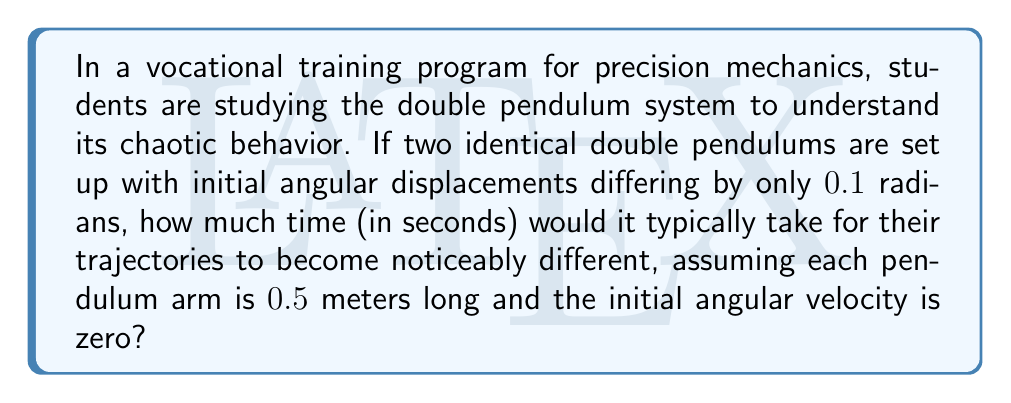Solve this math problem. To solve this problem, we need to consider the Lyapunov exponent of a double pendulum system. The Lyapunov exponent measures the rate at which nearby trajectories separate.

Step 1: The Lyapunov exponent for a double pendulum is approximately:
$$\lambda \approx \sqrt{\frac{g}{l}}$$
where $g$ is the acceleration due to gravity (9.8 m/s^2) and $l$ is the length of each pendulum arm.

Step 2: Calculate the Lyapunov exponent:
$$\lambda \approx \sqrt{\frac{9.8}{0.5}} \approx 4.43 \text{ s}^{-1}$$

Step 3: The divergence of trajectories follows an exponential law:
$$d(t) = d_0 e^{\lambda t}$$
where $d_0$ is the initial separation and $d(t)$ is the separation at time $t$.

Step 4: We want to find the time when the separation becomes "noticeable." Let's define this as when the separation reaches 1 radian (about 57°). So:
$$1 = 0.1 e^{4.43t}$$

Step 5: Solve for $t$:
$$e^{4.43t} = 10$$
$$4.43t = \ln(10)$$
$$t = \frac{\ln(10)}{4.43} \approx 0.52 \text{ seconds}$$

Therefore, it would take approximately 0.52 seconds for the trajectories to become noticeably different.
Answer: 0.52 seconds 